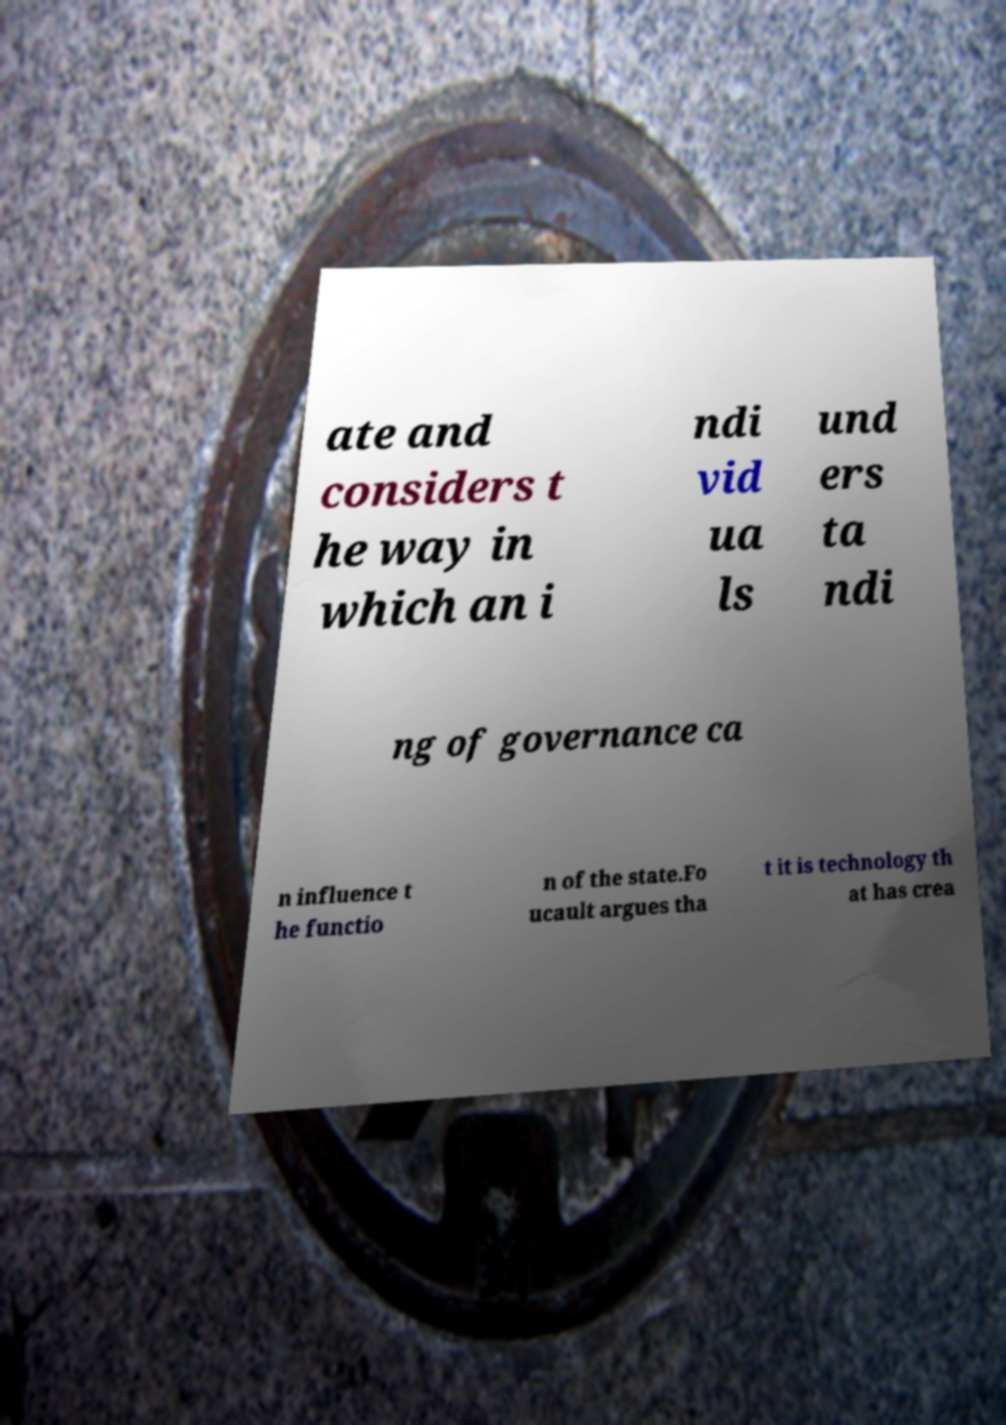There's text embedded in this image that I need extracted. Can you transcribe it verbatim? ate and considers t he way in which an i ndi vid ua ls und ers ta ndi ng of governance ca n influence t he functio n of the state.Fo ucault argues tha t it is technology th at has crea 